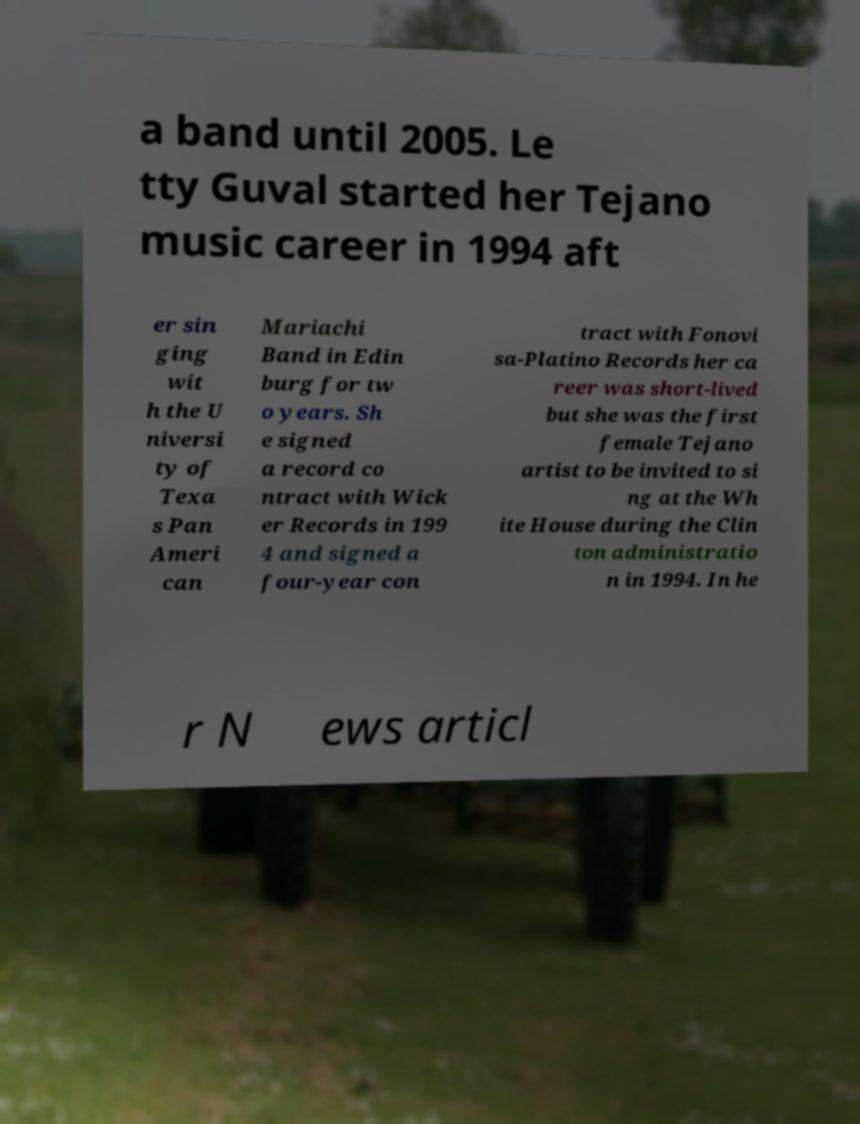There's text embedded in this image that I need extracted. Can you transcribe it verbatim? a band until 2005. Le tty Guval started her Tejano music career in 1994 aft er sin ging wit h the U niversi ty of Texa s Pan Ameri can Mariachi Band in Edin burg for tw o years. Sh e signed a record co ntract with Wick er Records in 199 4 and signed a four-year con tract with Fonovi sa-Platino Records her ca reer was short-lived but she was the first female Tejano artist to be invited to si ng at the Wh ite House during the Clin ton administratio n in 1994. In he r N ews articl 